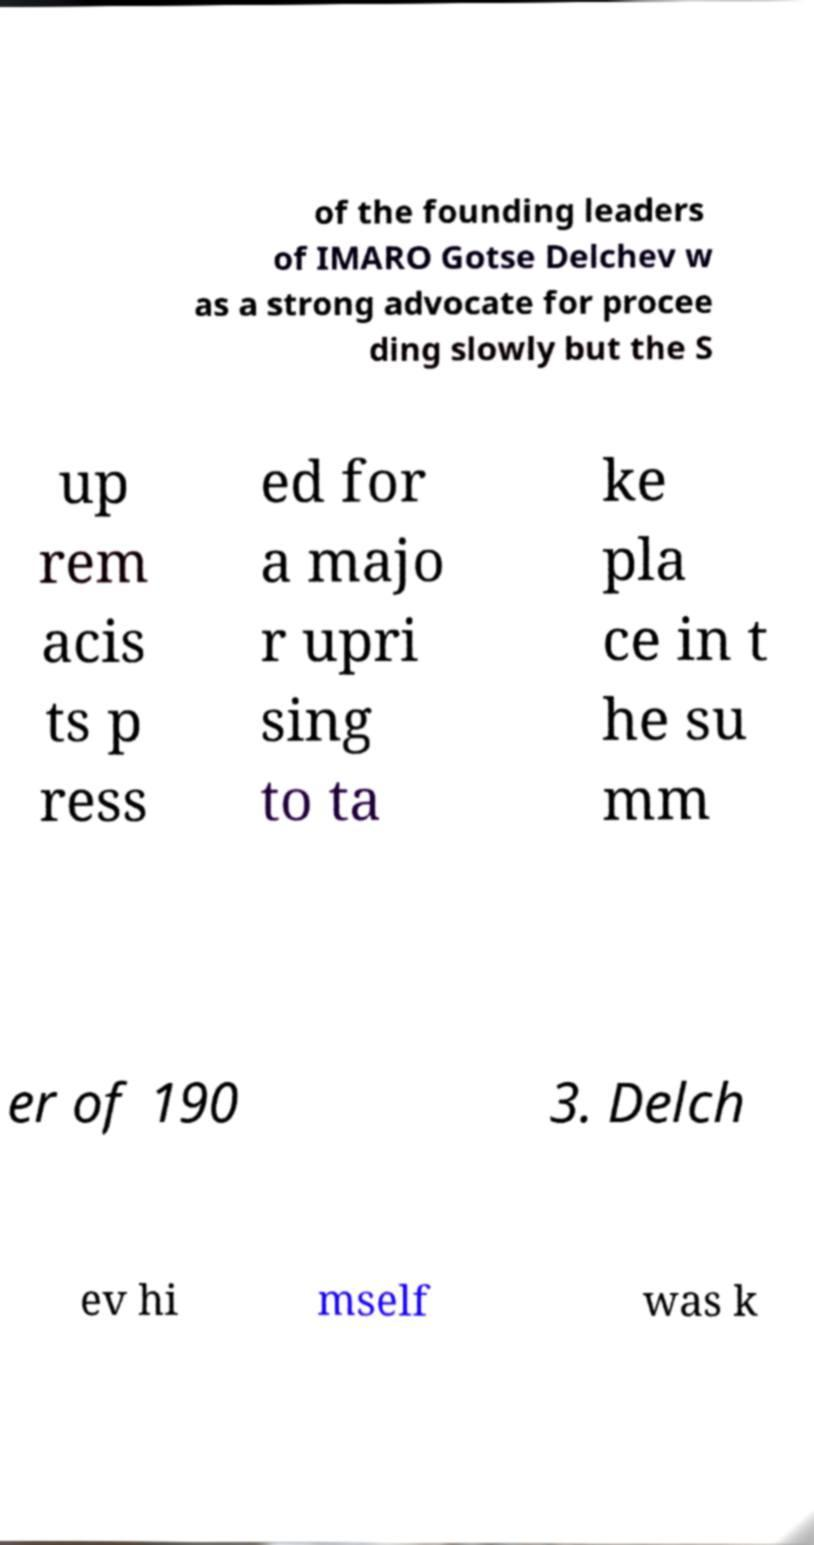There's text embedded in this image that I need extracted. Can you transcribe it verbatim? of the founding leaders of IMARO Gotse Delchev w as a strong advocate for procee ding slowly but the S up rem acis ts p ress ed for a majo r upri sing to ta ke pla ce in t he su mm er of 190 3. Delch ev hi mself was k 